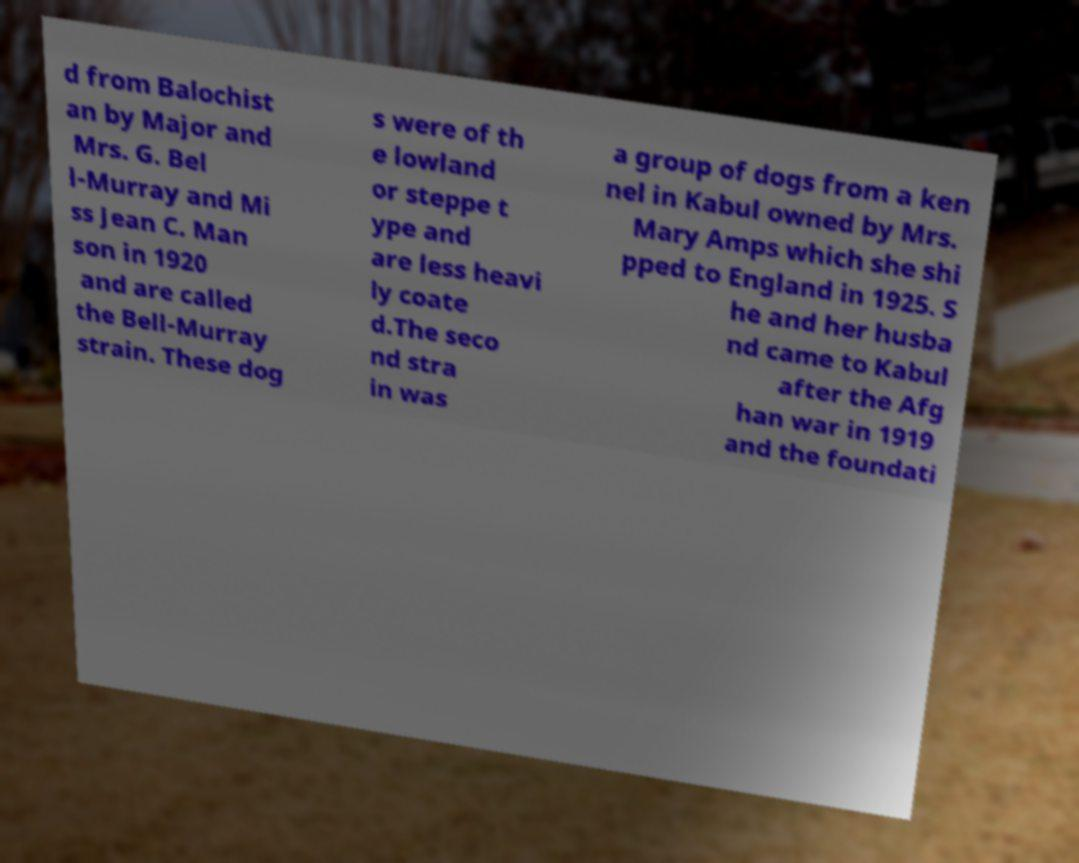For documentation purposes, I need the text within this image transcribed. Could you provide that? d from Balochist an by Major and Mrs. G. Bel l-Murray and Mi ss Jean C. Man son in 1920 and are called the Bell-Murray strain. These dog s were of th e lowland or steppe t ype and are less heavi ly coate d.The seco nd stra in was a group of dogs from a ken nel in Kabul owned by Mrs. Mary Amps which she shi pped to England in 1925. S he and her husba nd came to Kabul after the Afg han war in 1919 and the foundati 